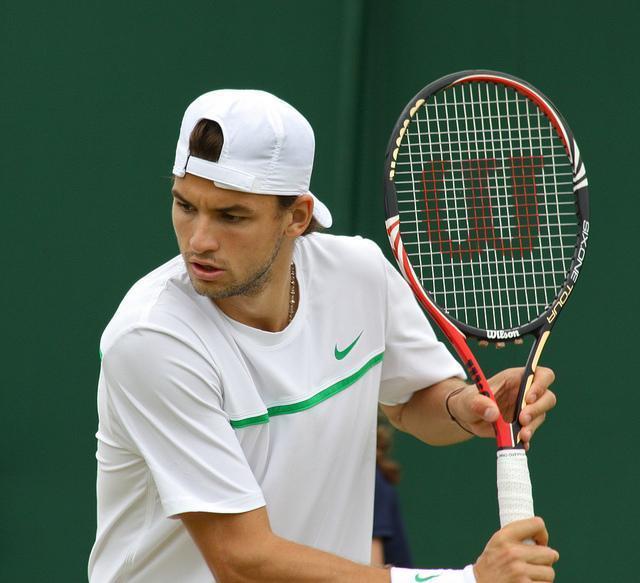How many people are there?
Give a very brief answer. 2. How many pieces of cheese pizza are there?
Give a very brief answer. 0. 